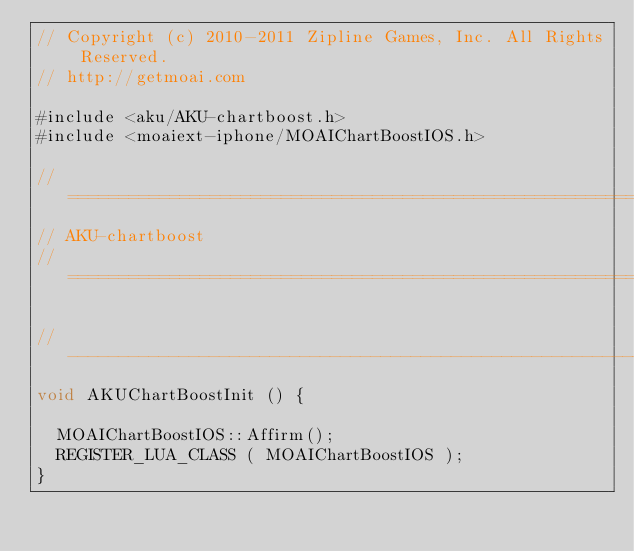<code> <loc_0><loc_0><loc_500><loc_500><_ObjectiveC_>// Copyright (c) 2010-2011 Zipline Games, Inc. All Rights Reserved.
// http://getmoai.com

#include <aku/AKU-chartboost.h>
#include <moaiext-iphone/MOAIChartBoostIOS.h>

//================================================================//
// AKU-chartboost
//================================================================//

//----------------------------------------------------------------//
void AKUChartBoostInit () {
	
	MOAIChartBoostIOS::Affirm();
	REGISTER_LUA_CLASS ( MOAIChartBoostIOS );
}</code> 